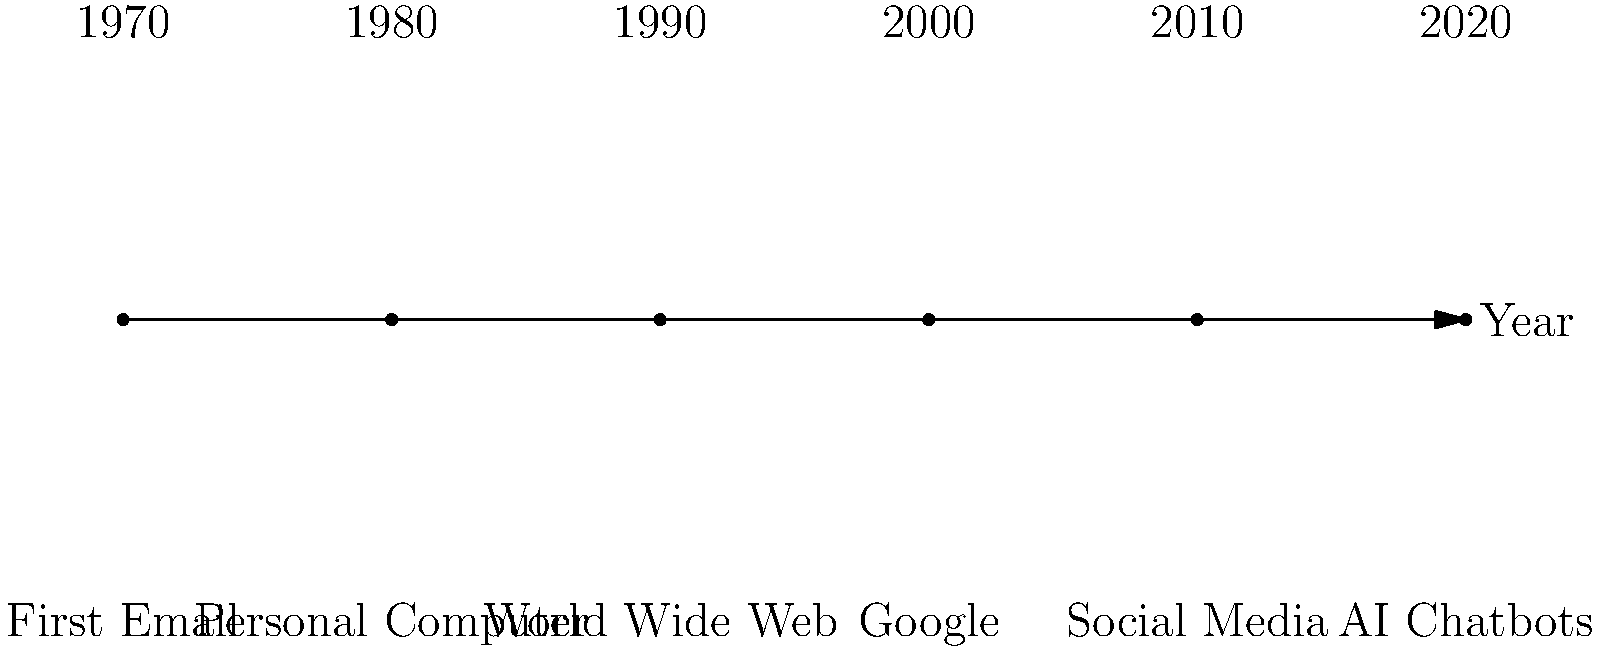Based on the timeline of digital technology advancements, which development would likely have the most significant impact on the field of digital humanities, and why? To answer this question, we need to consider each technological advancement and its potential impact on digital humanities:

1. First Email (1970): While important for communication, it has limited direct impact on digital humanities research methods.

2. Personal Computer (1980): Significant for individual research, but not transformative for the field as a whole.

3. World Wide Web (1990): This is a crucial development for digital humanities because:
   a) It allows for global collaboration and sharing of research.
   b) It provides access to vast amounts of digitized cultural artifacts and texts.
   c) It enables the creation of online archives and databases.
   d) It facilitates new forms of digital scholarship and publication.

4. Google (2000): Important for information retrieval, but builds upon the World Wide Web.

5. Social Media (2010): Useful for networking and dissemination, but not fundamentally changing research methodologies.

6. AI Chatbots (2020): While promising, their impact on digital humanities is still emerging and not as established as the World Wide Web.

The World Wide Web stands out as the most impactful development for digital humanities. It fundamentally changed how researchers access, analyze, and share information, forming the backbone of many digital humanities projects and methodologies.
Answer: World Wide Web (1990) 